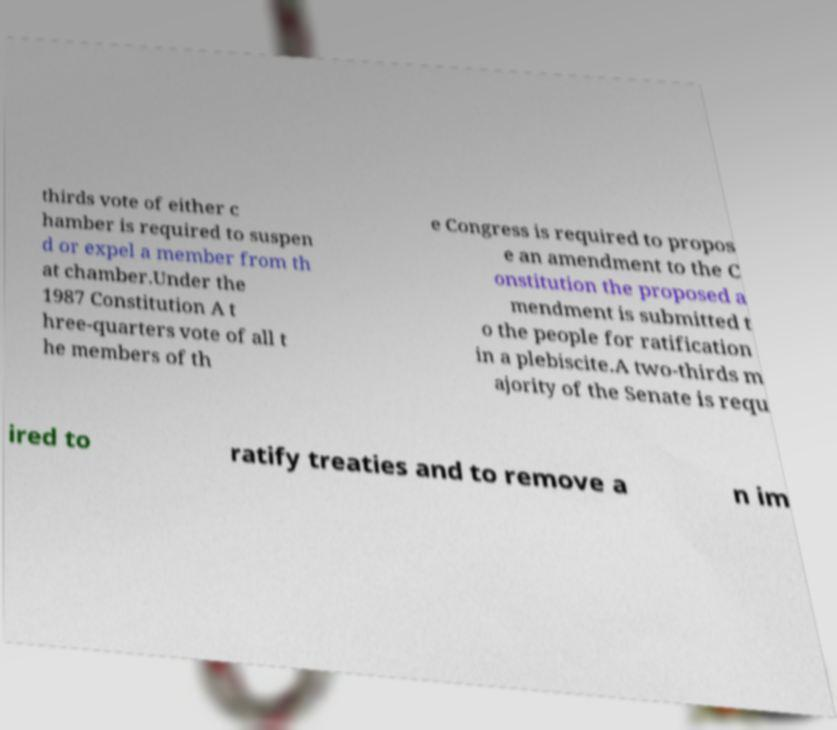Please read and relay the text visible in this image. What does it say? thirds vote of either c hamber is required to suspen d or expel a member from th at chamber.Under the 1987 Constitution A t hree-quarters vote of all t he members of th e Congress is required to propos e an amendment to the C onstitution the proposed a mendment is submitted t o the people for ratification in a plebiscite.A two-thirds m ajority of the Senate is requ ired to ratify treaties and to remove a n im 